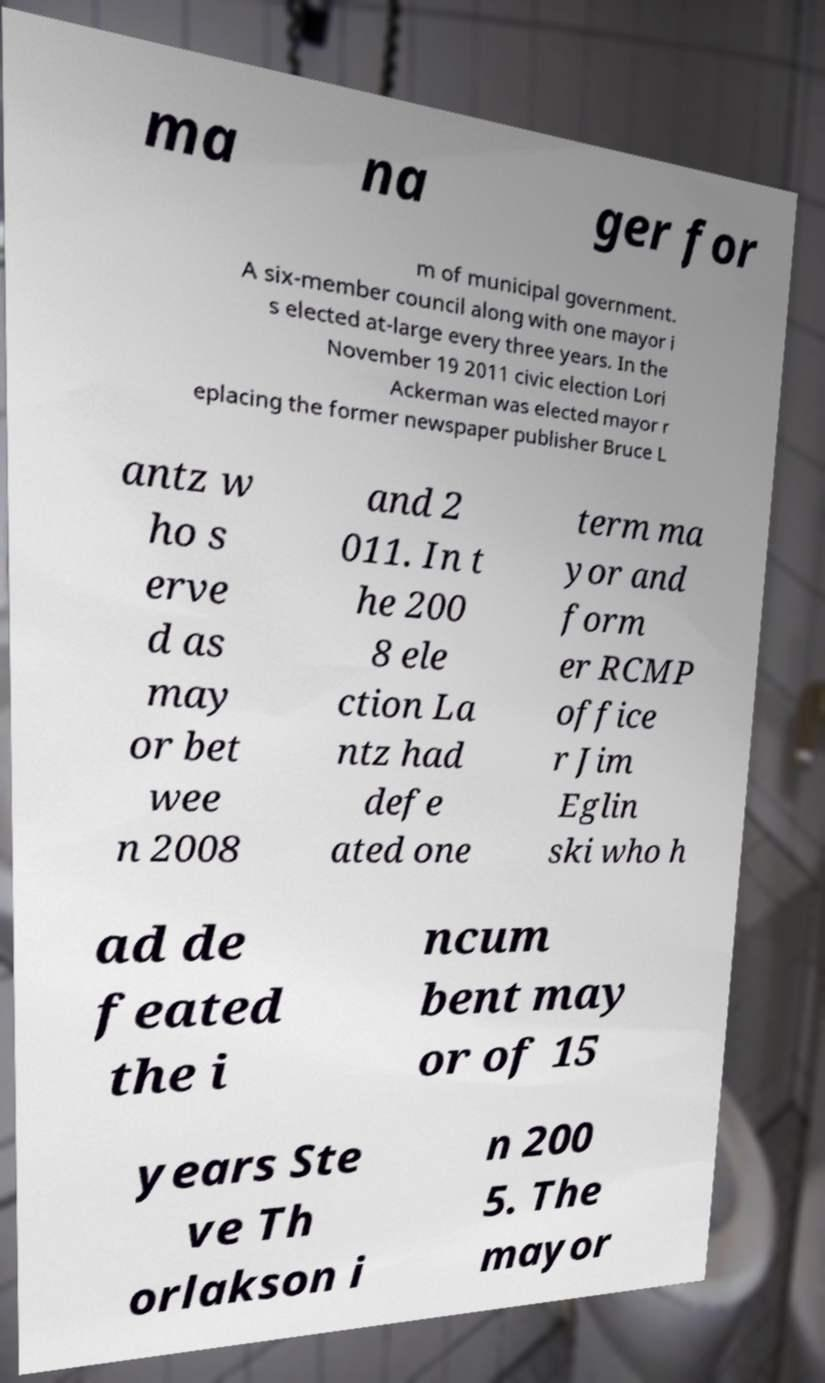Can you accurately transcribe the text from the provided image for me? ma na ger for m of municipal government. A six-member council along with one mayor i s elected at-large every three years. In the November 19 2011 civic election Lori Ackerman was elected mayor r eplacing the former newspaper publisher Bruce L antz w ho s erve d as may or bet wee n 2008 and 2 011. In t he 200 8 ele ction La ntz had defe ated one term ma yor and form er RCMP office r Jim Eglin ski who h ad de feated the i ncum bent may or of 15 years Ste ve Th orlakson i n 200 5. The mayor 